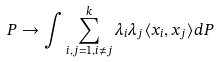<formula> <loc_0><loc_0><loc_500><loc_500>P \to \int \sum _ { i , j = 1 , i \neq j } ^ { k } \lambda _ { i } \lambda _ { j } \langle x _ { i } , x _ { j } \rangle d P</formula> 